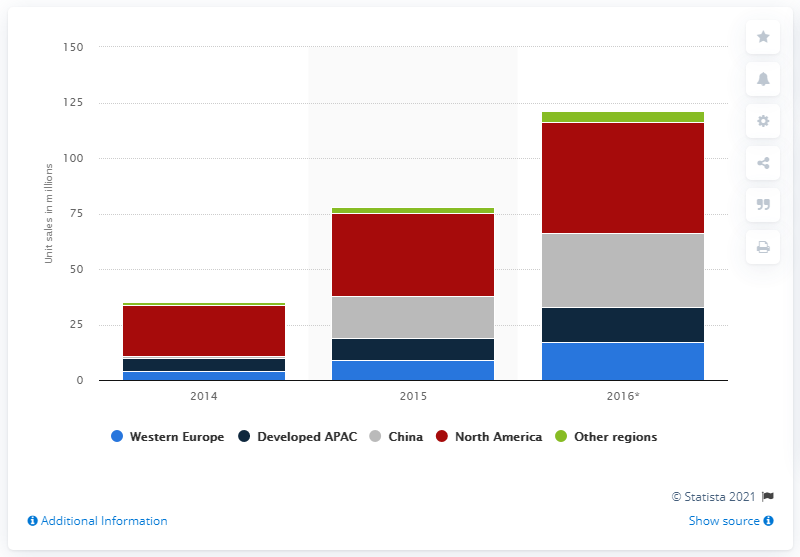Indicate a few pertinent items in this graphic. It is predicted that a large number of wearable devices will be sold in Western Europe in 2016. 